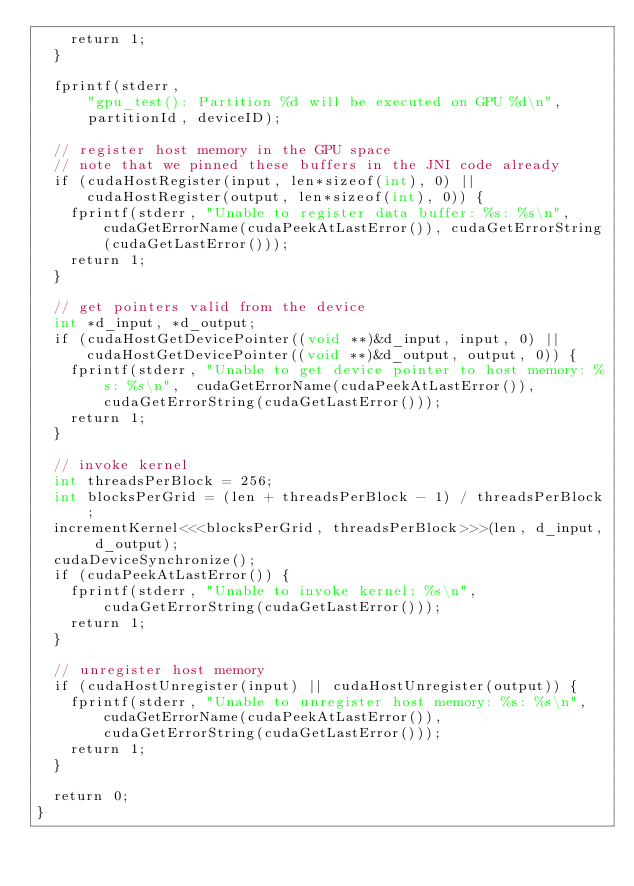Convert code to text. <code><loc_0><loc_0><loc_500><loc_500><_Cuda_>		return 1;
	}

	fprintf(stderr,
			"gpu_test(): Partition %d will be executed on GPU %d\n",
			partitionId, deviceID);
	
	// register host memory in the GPU space
	// note that we pinned these buffers in the JNI code already
	if (cudaHostRegister(input, len*sizeof(int), 0) || cudaHostRegister(output, len*sizeof(int), 0)) {
		fprintf(stderr, "Unable to register data buffer: %s: %s\n",  cudaGetErrorName(cudaPeekAtLastError()), cudaGetErrorString(cudaGetLastError()));
		return 1;
	}
	
	// get pointers valid from the device 
	int *d_input, *d_output;
	if (cudaHostGetDevicePointer((void **)&d_input, input, 0) || cudaHostGetDevicePointer((void **)&d_output, output, 0)) {
		fprintf(stderr, "Unable to get device pointer to host memory: %s: %s\n",  cudaGetErrorName(cudaPeekAtLastError()), cudaGetErrorString(cudaGetLastError()));
		return 1;
	}
	
	// invoke kernel
	int threadsPerBlock = 256; 
	int blocksPerGrid = (len + threadsPerBlock - 1) / threadsPerBlock;
	incrementKernel<<<blocksPerGrid, threadsPerBlock>>>(len, d_input, d_output);
	cudaDeviceSynchronize();
	if (cudaPeekAtLastError()) {
		fprintf(stderr, "Unable to invoke kernel: %s\n",  cudaGetErrorString(cudaGetLastError()));
		return 1;
	}
		
	// unregister host memory
	if (cudaHostUnregister(input) || cudaHostUnregister(output)) {
		fprintf(stderr, "Unable to unregister host memory: %s: %s\n",  cudaGetErrorName(cudaPeekAtLastError()),  cudaGetErrorString(cudaGetLastError()));
		return 1;
	}
	
	return 0;
}

</code> 